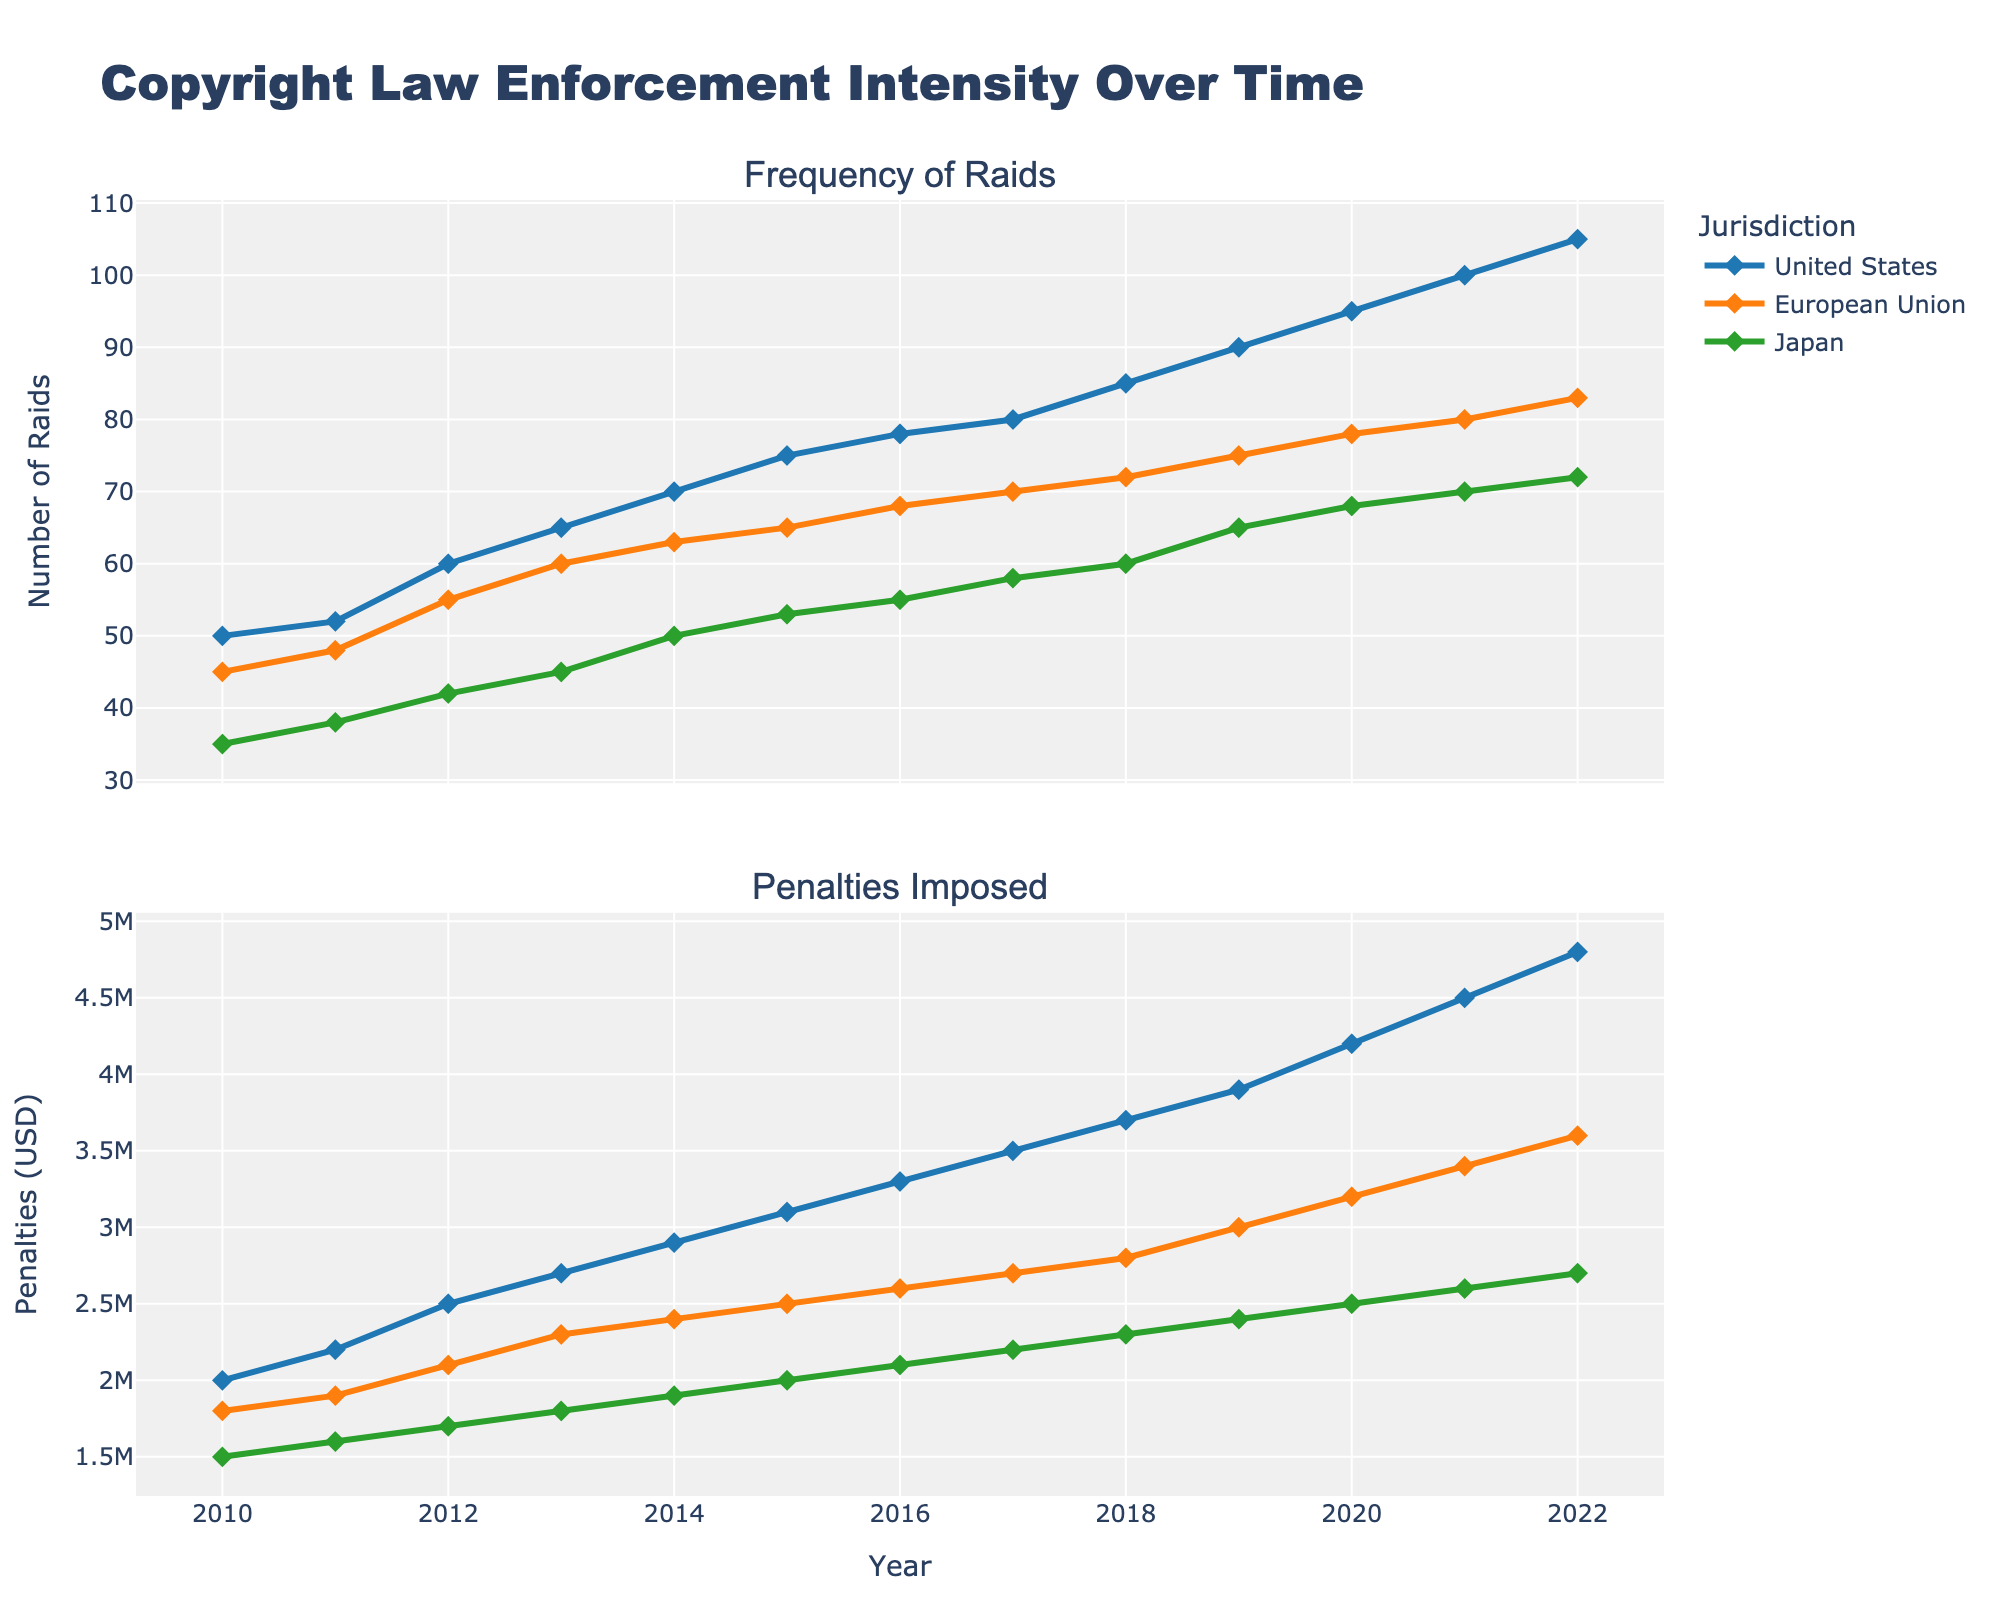what is the title of the figure? The title is prominently displayed at the top of the figure in larger font size and often bold. The title of this figure is "Copyright Law Enforcement Intensity Over Time"
Answer: Copyright Law Enforcement Intensity Over Time What colors are used for the different jurisdictions? The figure uses different colors to distinguish between jurisdictions. Each time series line can be observed in different color coding. The United States is typically shown in blue, the European Union in orange, and Japan in green.
Answer: Blue, Orange, Green How many raids were conducted in the United States in 2015 compared to Japan in the same year? To answer this, we look at the frequency of raids in 2015 on the line plot for both the United States and Japan. The plot points show that the United States had 75 raids, while Japan had 53 raids.
Answer: 75 for the United States and 53 for Japan What is the overall trend in the number of raids in the European Union from 2010 to 2022? Observing the line representing the frequency of raids in the European Union, we notice an increasing trend, starting at 45 raids in 2010 and rising to 83 raids by 2022.
Answer: Increasing trend How does the total number of raids in Japan change from 2010 to 2022? Checking the data points of Japan over the years, we see that the number of raids in Japan increased from 35 in 2010 to 72 in 2022, indicating an overall rising trend.
Answer: Increased from 35 to 72 What is the difference in penalties imposed between 2018 and 2022 in the European Union? By referencing the penalties imposed in the European Union, we see that in 2018 they were $2,800,000, which increased to $3,600,000 in 2022. Hence, the difference is $3,600,000 - $2,800,000 = $800,000.
Answer: $800,000 Which year shows the maximum difference in penalties imposed between the United States and Japan? Reviewing the plot for penalties imposed, we see that the greatest difference is in 2022, where the penalties in the United States are $4,800,000 and in Japan are $2,700,000. The difference calculated is $4,800,000 - $2,700,000 = $2,100,000.
Answer: 2022 Compare the trend of penalties imposed in the United States and the European Union from 2010 to 2022. The plot shows both regions have an upward trend; however, the penalties imposed in the United States rise steeply compared to the more gradual increase in the European Union. The starting and ending values for the U.S. are much higher than those for the E.U.
Answer: Both upward, but steeper in the United States What is the relationship between the frequency of raids and penalties imposed in the United States? Observing the plot for the United States, both the number of raids and penalties imposed show a steadily increasing trend over time, suggesting a positive correlation between the two variables.
Answer: Positive correlation 